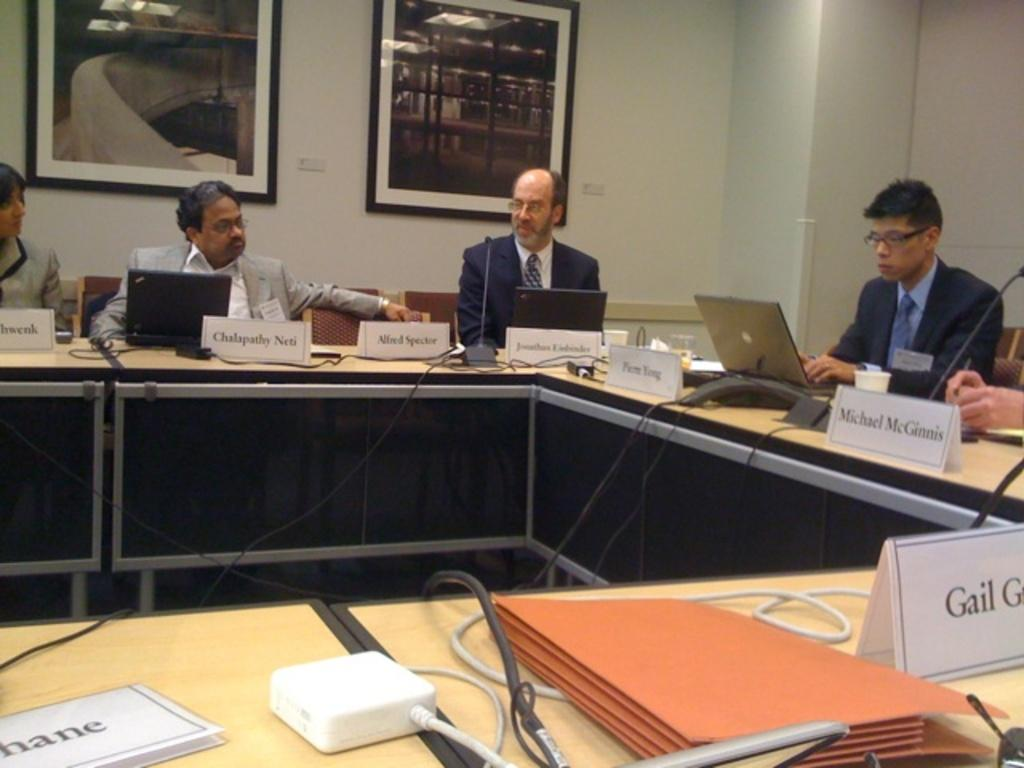<image>
Create a compact narrative representing the image presented. Males sit around a table with their names on a card infront of them, one of those names is Michael McGinnis. 